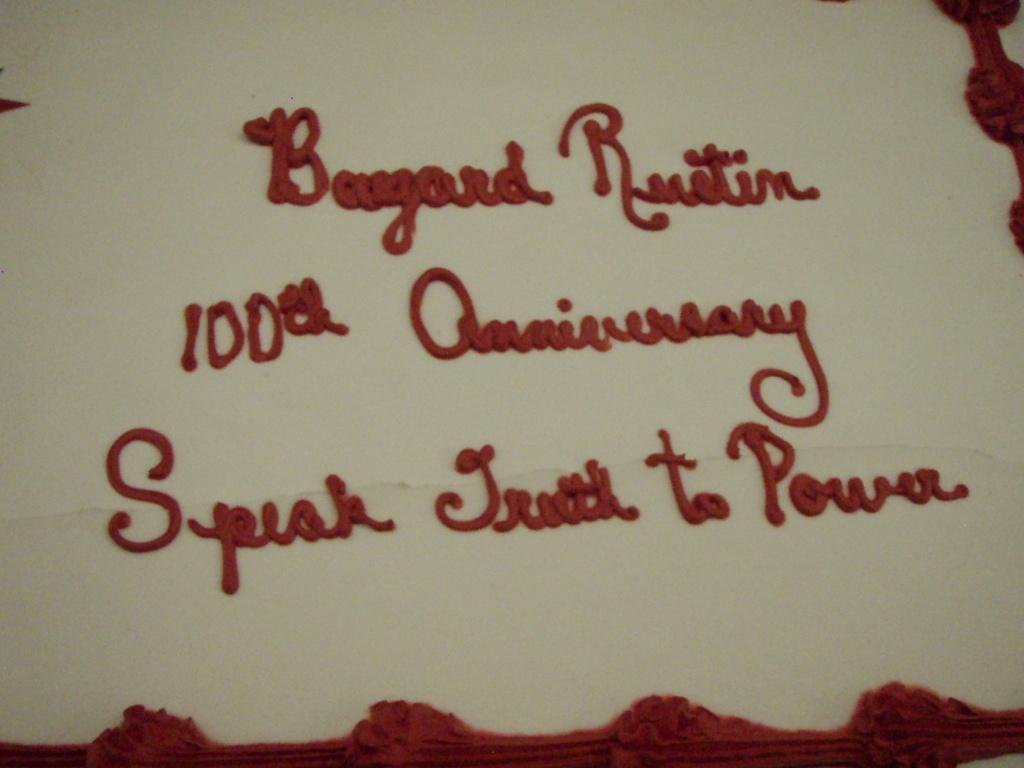What type of dessert is visible in the image? There is a white color cake in the image. What additional feature can be seen on the cake? There is red color text on the cake. What type of elbow support is visible in the image? There is no elbow support present in the image. Is there a rainstorm occurring in the image? No, there is no rainstorm present in the image. Who is sitting on the throne in the image? There is no throne present in the image. 